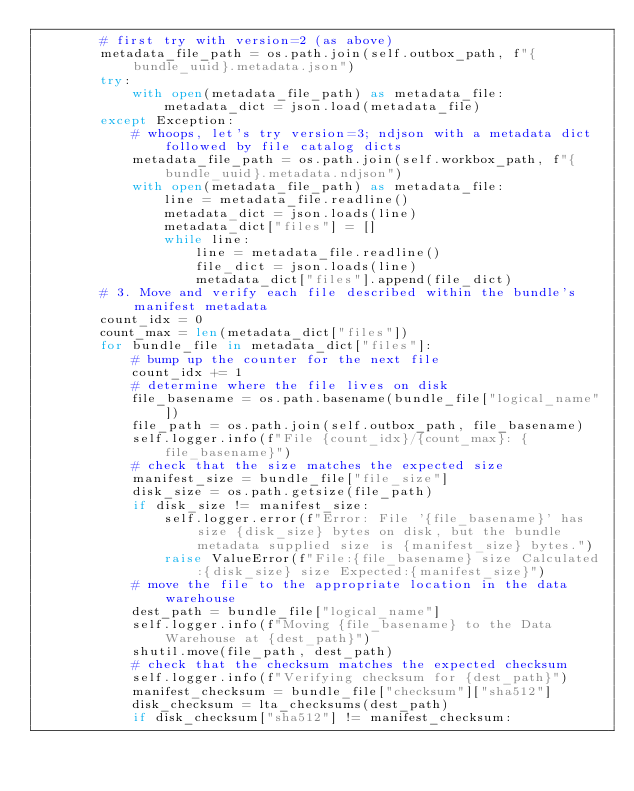Convert code to text. <code><loc_0><loc_0><loc_500><loc_500><_Python_>        # first try with version=2 (as above)
        metadata_file_path = os.path.join(self.outbox_path, f"{bundle_uuid}.metadata.json")
        try:
            with open(metadata_file_path) as metadata_file:
                metadata_dict = json.load(metadata_file)
        except Exception:
            # whoops, let's try version=3; ndjson with a metadata dict followed by file catalog dicts
            metadata_file_path = os.path.join(self.workbox_path, f"{bundle_uuid}.metadata.ndjson")
            with open(metadata_file_path) as metadata_file:
                line = metadata_file.readline()
                metadata_dict = json.loads(line)
                metadata_dict["files"] = []
                while line:
                    line = metadata_file.readline()
                    file_dict = json.loads(line)
                    metadata_dict["files"].append(file_dict)
        # 3. Move and verify each file described within the bundle's manifest metadata
        count_idx = 0
        count_max = len(metadata_dict["files"])
        for bundle_file in metadata_dict["files"]:
            # bump up the counter for the next file
            count_idx += 1
            # determine where the file lives on disk
            file_basename = os.path.basename(bundle_file["logical_name"])
            file_path = os.path.join(self.outbox_path, file_basename)
            self.logger.info(f"File {count_idx}/{count_max}: {file_basename}")
            # check that the size matches the expected size
            manifest_size = bundle_file["file_size"]
            disk_size = os.path.getsize(file_path)
            if disk_size != manifest_size:
                self.logger.error(f"Error: File '{file_basename}' has size {disk_size} bytes on disk, but the bundle metadata supplied size is {manifest_size} bytes.")
                raise ValueError(f"File:{file_basename} size Calculated:{disk_size} size Expected:{manifest_size}")
            # move the file to the appropriate location in the data warehouse
            dest_path = bundle_file["logical_name"]
            self.logger.info(f"Moving {file_basename} to the Data Warehouse at {dest_path}")
            shutil.move(file_path, dest_path)
            # check that the checksum matches the expected checksum
            self.logger.info(f"Verifying checksum for {dest_path}")
            manifest_checksum = bundle_file["checksum"]["sha512"]
            disk_checksum = lta_checksums(dest_path)
            if disk_checksum["sha512"] != manifest_checksum:</code> 